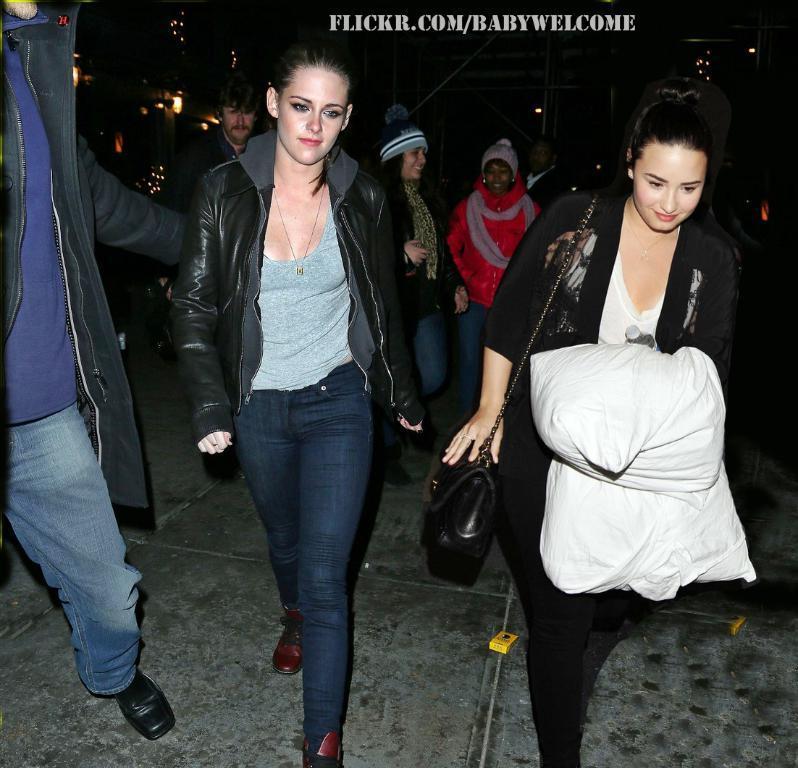How would you summarize this image in a sentence or two? In this image I can see there are two women visible in the foreground and on the left side I can see a person and background I can see few persons and lights and at the top I can see the text and this picture is taken during night. 